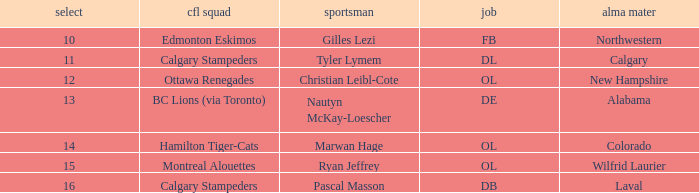What position does Christian Leibl-Cote play? OL. 